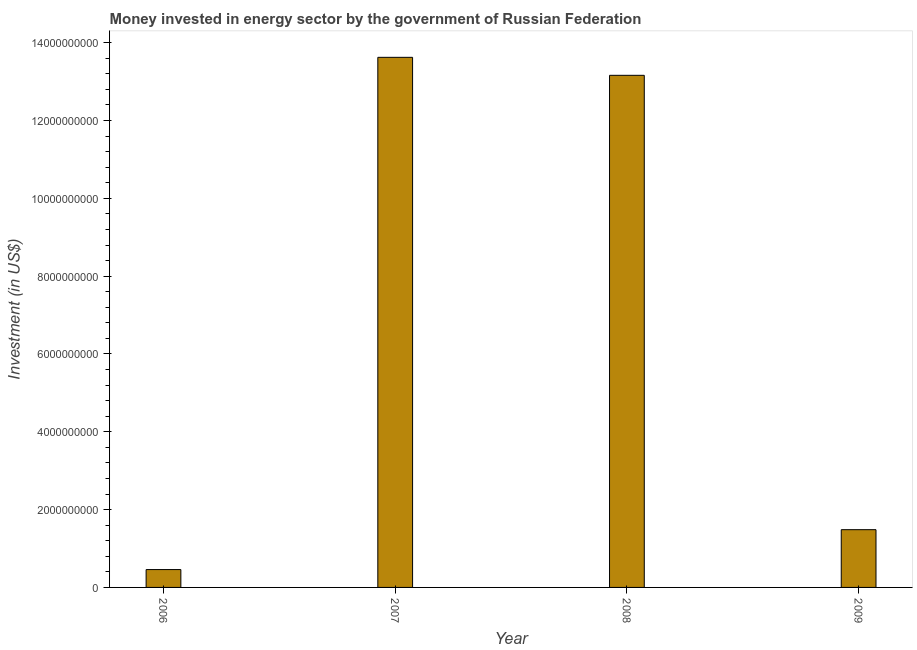Does the graph contain any zero values?
Give a very brief answer. No. What is the title of the graph?
Give a very brief answer. Money invested in energy sector by the government of Russian Federation. What is the label or title of the X-axis?
Your response must be concise. Year. What is the label or title of the Y-axis?
Give a very brief answer. Investment (in US$). What is the investment in energy in 2009?
Provide a short and direct response. 1.48e+09. Across all years, what is the maximum investment in energy?
Your response must be concise. 1.36e+1. Across all years, what is the minimum investment in energy?
Offer a very short reply. 4.59e+08. In which year was the investment in energy minimum?
Provide a short and direct response. 2006. What is the sum of the investment in energy?
Keep it short and to the point. 2.87e+1. What is the difference between the investment in energy in 2007 and 2008?
Provide a short and direct response. 4.62e+08. What is the average investment in energy per year?
Provide a short and direct response. 7.18e+09. What is the median investment in energy?
Your answer should be compact. 7.32e+09. Do a majority of the years between 2008 and 2009 (inclusive) have investment in energy greater than 8800000000 US$?
Your answer should be compact. No. What is the ratio of the investment in energy in 2006 to that in 2008?
Provide a short and direct response. 0.04. Is the investment in energy in 2006 less than that in 2008?
Offer a terse response. Yes. What is the difference between the highest and the second highest investment in energy?
Provide a short and direct response. 4.62e+08. Is the sum of the investment in energy in 2007 and 2009 greater than the maximum investment in energy across all years?
Keep it short and to the point. Yes. What is the difference between the highest and the lowest investment in energy?
Your response must be concise. 1.32e+1. In how many years, is the investment in energy greater than the average investment in energy taken over all years?
Make the answer very short. 2. Are all the bars in the graph horizontal?
Your response must be concise. No. What is the difference between two consecutive major ticks on the Y-axis?
Your response must be concise. 2.00e+09. Are the values on the major ticks of Y-axis written in scientific E-notation?
Provide a succinct answer. No. What is the Investment (in US$) in 2006?
Offer a very short reply. 4.59e+08. What is the Investment (in US$) in 2007?
Your answer should be compact. 1.36e+1. What is the Investment (in US$) in 2008?
Your response must be concise. 1.32e+1. What is the Investment (in US$) of 2009?
Offer a very short reply. 1.48e+09. What is the difference between the Investment (in US$) in 2006 and 2007?
Provide a short and direct response. -1.32e+1. What is the difference between the Investment (in US$) in 2006 and 2008?
Ensure brevity in your answer.  -1.27e+1. What is the difference between the Investment (in US$) in 2006 and 2009?
Offer a terse response. -1.03e+09. What is the difference between the Investment (in US$) in 2007 and 2008?
Provide a succinct answer. 4.62e+08. What is the difference between the Investment (in US$) in 2007 and 2009?
Offer a terse response. 1.21e+1. What is the difference between the Investment (in US$) in 2008 and 2009?
Ensure brevity in your answer.  1.17e+1. What is the ratio of the Investment (in US$) in 2006 to that in 2007?
Keep it short and to the point. 0.03. What is the ratio of the Investment (in US$) in 2006 to that in 2008?
Make the answer very short. 0.04. What is the ratio of the Investment (in US$) in 2006 to that in 2009?
Your answer should be very brief. 0.31. What is the ratio of the Investment (in US$) in 2007 to that in 2008?
Offer a very short reply. 1.03. What is the ratio of the Investment (in US$) in 2007 to that in 2009?
Offer a terse response. 9.18. What is the ratio of the Investment (in US$) in 2008 to that in 2009?
Your answer should be compact. 8.87. 